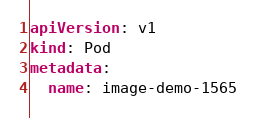<code> <loc_0><loc_0><loc_500><loc_500><_YAML_>apiVersion: v1
kind: Pod
metadata:
  name: image-demo-1565</code> 